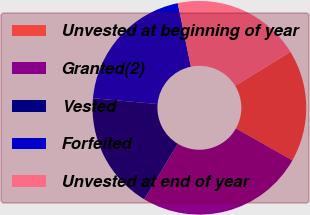Convert chart. <chart><loc_0><loc_0><loc_500><loc_500><pie_chart><fcel>Unvested at beginning of year<fcel>Granted(2)<fcel>Vested<fcel>Forfeited<fcel>Unvested at end of year<nl><fcel>16.96%<fcel>25.43%<fcel>17.8%<fcel>20.33%<fcel>19.48%<nl></chart> 